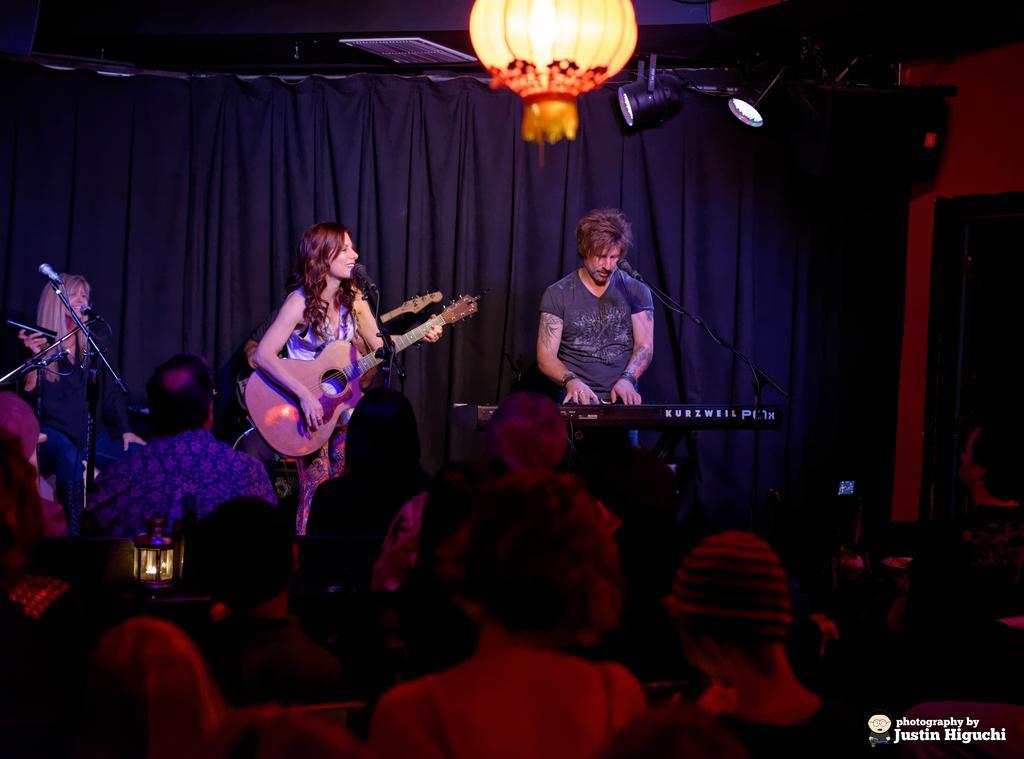In one or two sentences, can you explain what this image depicts? In this image I see 2 women and a man who are on the stage and all of them are in front of the mics and I see that this woman is holding a guitar and this man is playing a keyboard and there are lot of people over here. In the background I see the curtain, lights and another person. 